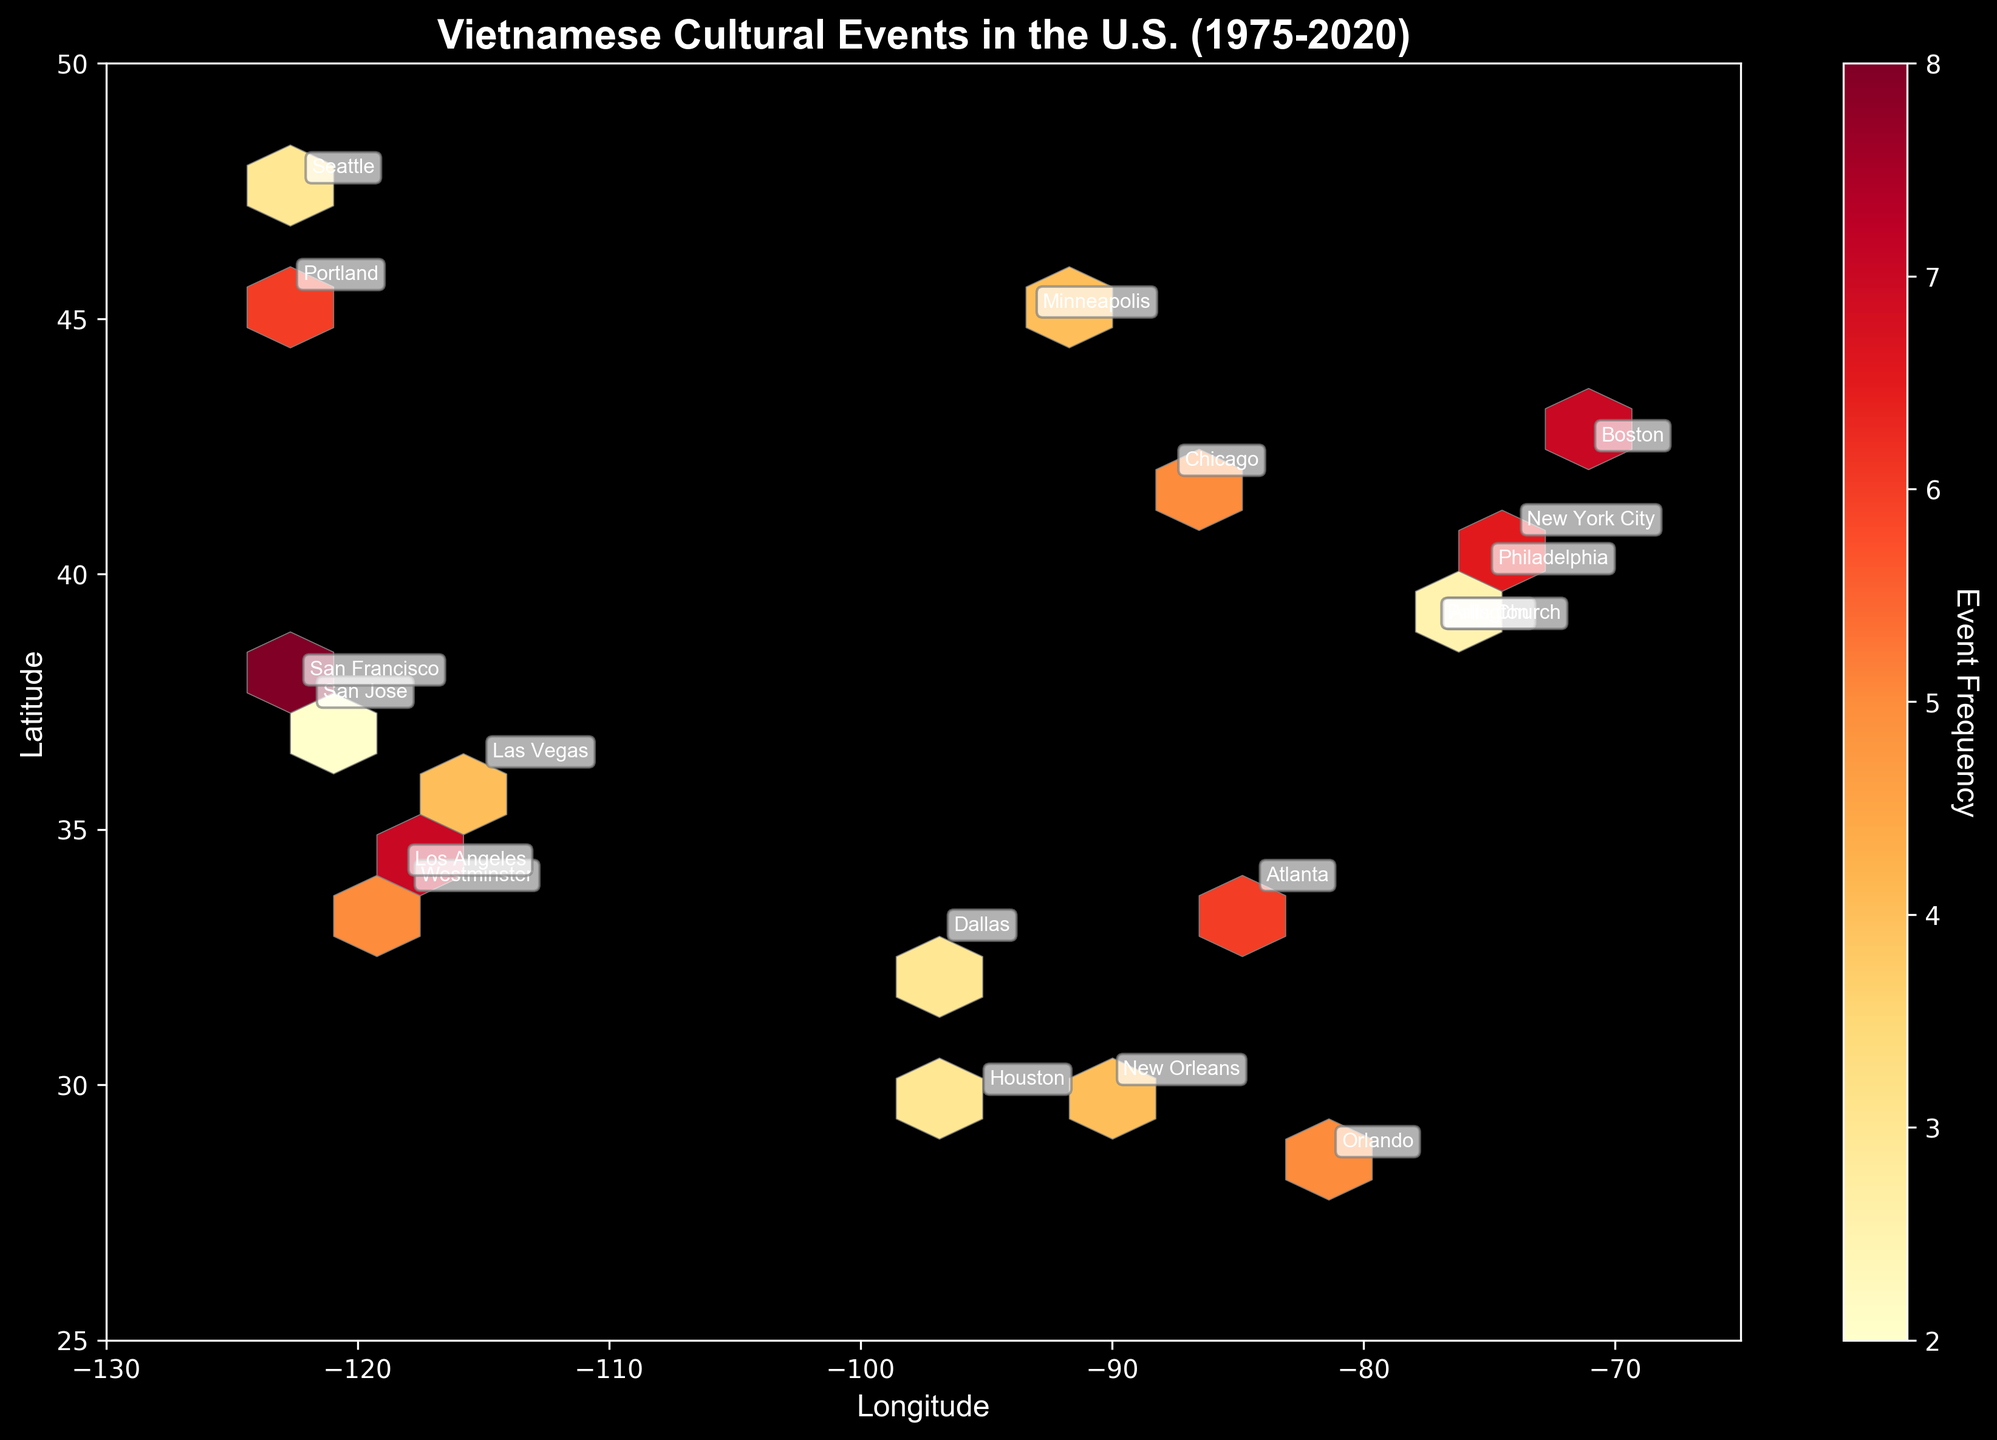What's the title of the plot? The title is typically found at the top of the plot, indicating the overall topic being visualized. Here, the title "Vietnamese Cultural Events in the U.S. (1975-2020)" informs us about the frequency and geographic spread of these events over the specified years.
Answer: Vietnamese Cultural Events in the U.S. (1975-2020) Which city had the highest frequency of events in 2010? To find this, look for annotations near the hexagons with the highest color intensity around the 2010 time frame. New York City appears most frequently in 2010 with a high event frequency of 9, represented by a darker color.
Answer: New York City What is the approximate range of latitudes and longitudes represented? The x-axis and y-axis label the geographic coordinates, specifically longitude and latitude. The range can be observed from these labels, which span roughly from -130 to -65 for longitude and 25 to 50 for latitude.
Answer: Longitude: -130 to -65, Latitude: 25 to 50 Can you identify the general region with the highest density of events? High density is indicated by darker hexagons. Observing the plot, California, especially around the cities of San Francisco and Los Angeles, shows a high density of events due to the darker shading in those areas.
Answer: California How does the event frequency in San Francisco compare to Orlando in 2020? Find the annotations and colors of the hexagons corresponding to these cities for the year 2020. San Francisco has a higher frequency (8) compared to Orlando (5). Darker shade indicates higher frequency.
Answer: San Francisco has a higher frequency Which state has multiple cities with a significant frequency of events? Identifying multiple notable hexagons within a state can signify multiple cities with significant event frequencies. California shows events in both San Jose and Los Angeles, indicating multiple significant cities.
Answer: California Are there more events concentrated in the eastern or western part of the U.S.? By comparing the density and color distribution of hexagons on the left (western) versus the right (eastern) side of the plot, it is clear that the western part, particularly California, has more concentrated and frequent events.
Answer: Western U.S What's the color scale used to represent event frequency? The color scale, often found with a color bar, uses a gradient going from lighter to darker colors. Here, it ranges from yellow (low frequency) to dark red (high frequency).
Answer: Yellow to dark red If you average the frequencies of events in Texas cities based on this plot, what is it? Texas has entries in Houston and Dallas with frequencies of 3 and 3, respectively. The sum is 6 and, with 2 cities, the average is 6/2 = 3.
Answer: 3 What general trend can you infer about the frequency of Vietnamese cultural events over time from 1975 to 2020? The progression can be inferred by observing the plot years and corresponding annotations. Over time, a significant increase in frequencies is observable, indicated by more frequent and darker-shaded hexagons in later years, suggesting a growing number of events.
Answer: Increasing trend in frequency over time 